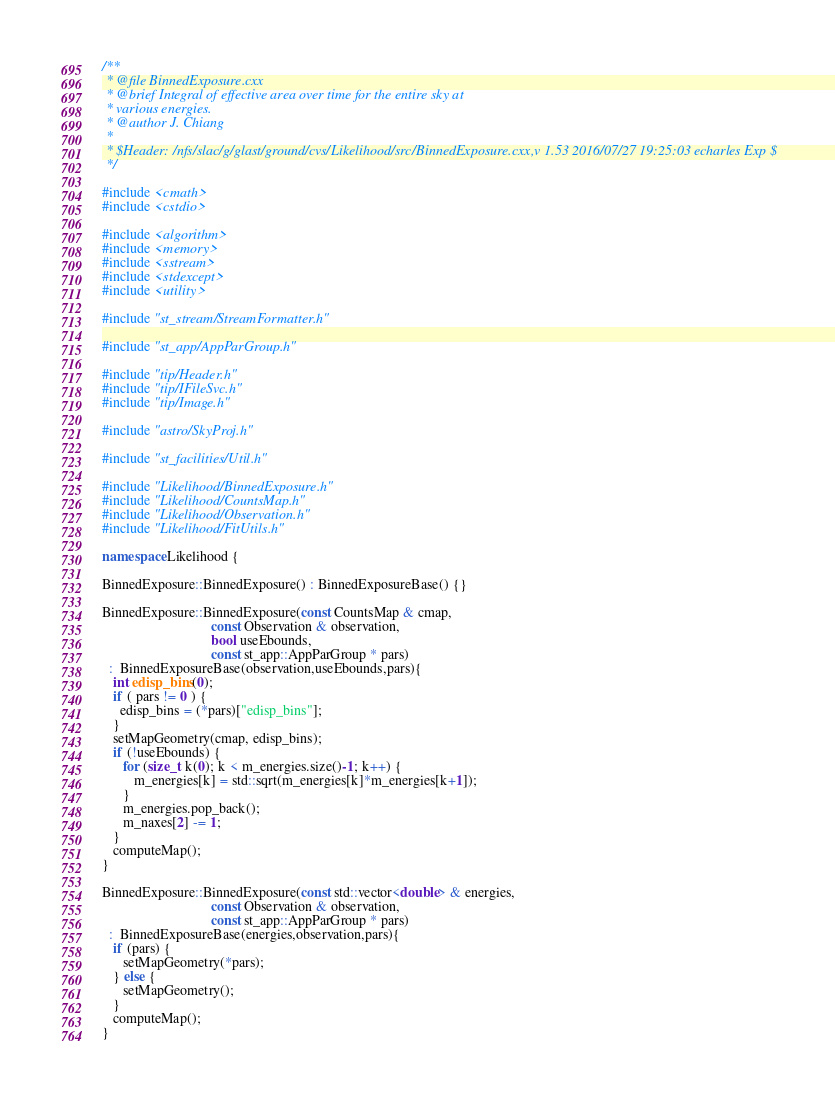Convert code to text. <code><loc_0><loc_0><loc_500><loc_500><_C++_>/**
 * @file BinnedExposure.cxx
 * @brief Integral of effective area over time for the entire sky at
 * various energies.
 * @author J. Chiang
 *
 * $Header: /nfs/slac/g/glast/ground/cvs/Likelihood/src/BinnedExposure.cxx,v 1.53 2016/07/27 19:25:03 echarles Exp $
 */

#include <cmath>
#include <cstdio>

#include <algorithm>
#include <memory>
#include <sstream>
#include <stdexcept>
#include <utility>

#include "st_stream/StreamFormatter.h"

#include "st_app/AppParGroup.h"

#include "tip/Header.h"
#include "tip/IFileSvc.h"
#include "tip/Image.h"

#include "astro/SkyProj.h"

#include "st_facilities/Util.h"

#include "Likelihood/BinnedExposure.h"
#include "Likelihood/CountsMap.h"
#include "Likelihood/Observation.h"
#include "Likelihood/FitUtils.h"

namespace Likelihood {

BinnedExposure::BinnedExposure() : BinnedExposureBase() {}

BinnedExposure::BinnedExposure(const CountsMap & cmap,
                               const Observation & observation,
                               bool useEbounds,
                               const st_app::AppParGroup * pars)
  :  BinnedExposureBase(observation,useEbounds,pars){
   int edisp_bins(0);
   if ( pars != 0 ) {
     edisp_bins = (*pars)["edisp_bins"];
   }
   setMapGeometry(cmap, edisp_bins);
   if (!useEbounds) {
      for (size_t k(0); k < m_energies.size()-1; k++) {
         m_energies[k] = std::sqrt(m_energies[k]*m_energies[k+1]);
      }
      m_energies.pop_back();
      m_naxes[2] -= 1;
   }
   computeMap();
}

BinnedExposure::BinnedExposure(const std::vector<double> & energies,
                               const Observation & observation,
                               const st_app::AppParGroup * pars) 
  :  BinnedExposureBase(energies,observation,pars){
   if (pars) {
      setMapGeometry(*pars);
   } else {
      setMapGeometry();
   }
   computeMap();
}
</code> 